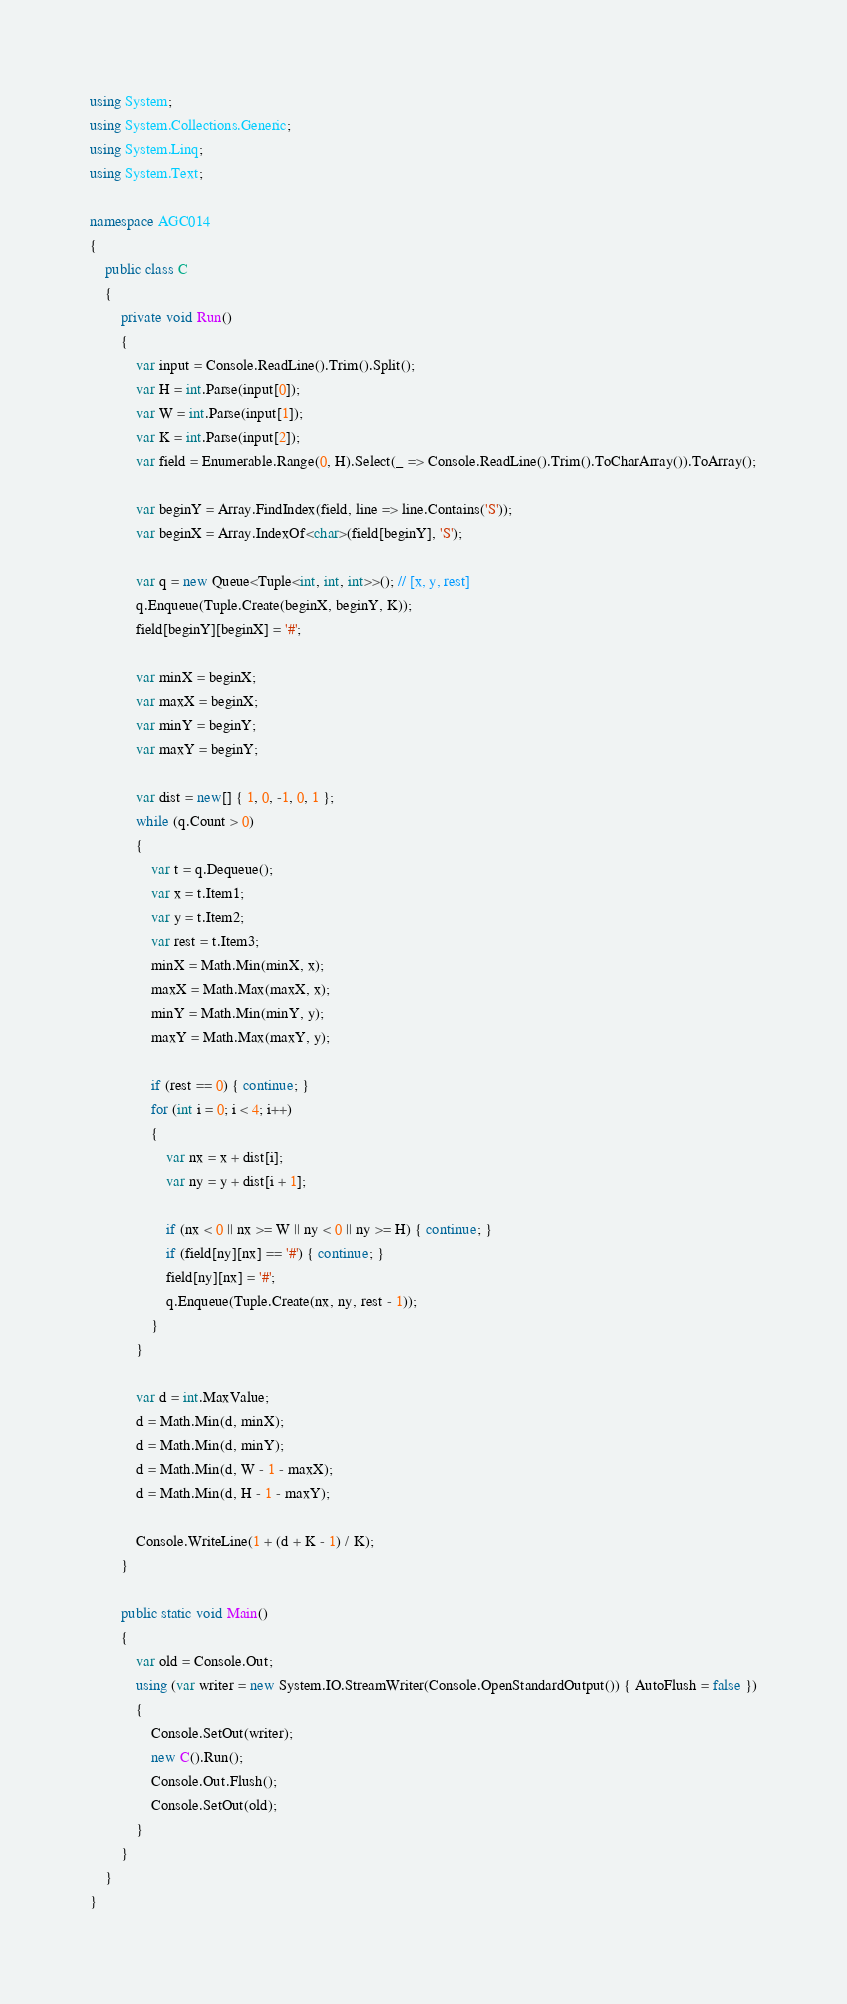Convert code to text. <code><loc_0><loc_0><loc_500><loc_500><_C#_>using System;
using System.Collections.Generic;
using System.Linq;
using System.Text;

namespace AGC014
{
    public class C
    {
        private void Run()
        {
            var input = Console.ReadLine().Trim().Split();
            var H = int.Parse(input[0]);
            var W = int.Parse(input[1]);
            var K = int.Parse(input[2]);
            var field = Enumerable.Range(0, H).Select(_ => Console.ReadLine().Trim().ToCharArray()).ToArray();

            var beginY = Array.FindIndex(field, line => line.Contains('S'));
            var beginX = Array.IndexOf<char>(field[beginY], 'S');

            var q = new Queue<Tuple<int, int, int>>(); // [x, y, rest]
            q.Enqueue(Tuple.Create(beginX, beginY, K));
            field[beginY][beginX] = '#';

            var minX = beginX;
            var maxX = beginX;
            var minY = beginY;
            var maxY = beginY;

            var dist = new[] { 1, 0, -1, 0, 1 };
            while (q.Count > 0)
            {
                var t = q.Dequeue();
                var x = t.Item1;
                var y = t.Item2;
                var rest = t.Item3;
                minX = Math.Min(minX, x);
                maxX = Math.Max(maxX, x);
                minY = Math.Min(minY, y);
                maxY = Math.Max(maxY, y);

                if (rest == 0) { continue; }
                for (int i = 0; i < 4; i++)
                {
                    var nx = x + dist[i];
                    var ny = y + dist[i + 1];

                    if (nx < 0 || nx >= W || ny < 0 || ny >= H) { continue; }
                    if (field[ny][nx] == '#') { continue; }
                    field[ny][nx] = '#';
                    q.Enqueue(Tuple.Create(nx, ny, rest - 1));
                }
            }

            var d = int.MaxValue;
            d = Math.Min(d, minX);
            d = Math.Min(d, minY);
            d = Math.Min(d, W - 1 - maxX);
            d = Math.Min(d, H - 1 - maxY);

            Console.WriteLine(1 + (d + K - 1) / K);
        }

        public static void Main()
        {
            var old = Console.Out;
            using (var writer = new System.IO.StreamWriter(Console.OpenStandardOutput()) { AutoFlush = false })
            {
                Console.SetOut(writer);
                new C().Run();
                Console.Out.Flush();
                Console.SetOut(old);
            }
        }
    }
}
</code> 